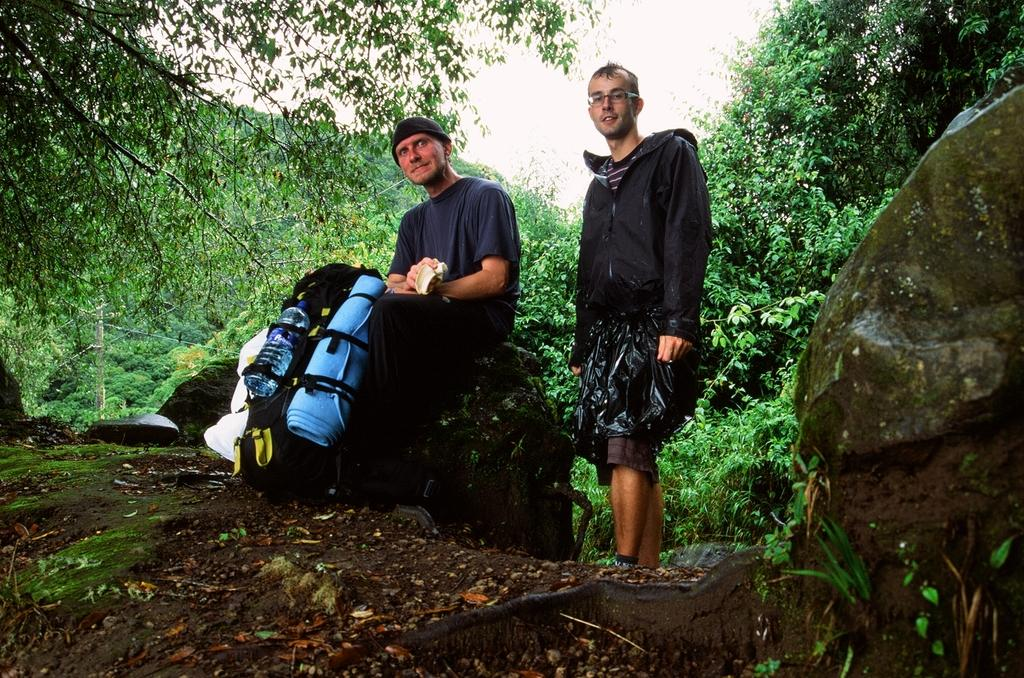How many people are in the image? There are three people in the image: two men and one woman. What is the woman doing in the image? The woman is sitting on a rock in the image. What is the woman holding in her hand? The woman is holding a bag in her hand. What is the position of one of the men in the image? One man is standing in the image. What can be seen in the background of the image? There are trees in the background of the image. What type of earth can be seen in the image? There is no specific type of earth mentioned or visible in the image. Can you describe the crook that the woman is using to sit on the rock? There is no crook present in the image; the woman is sitting on a rock without any additional support. 